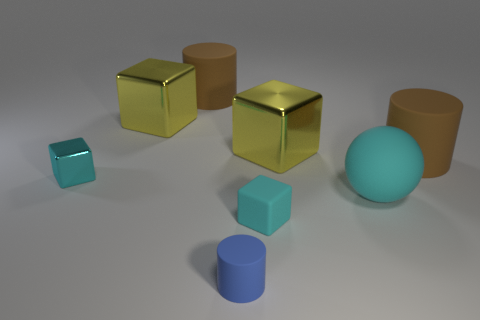What is the material of the ball that is the same color as the tiny shiny block?
Your answer should be compact. Rubber. How many cubes are behind the cyan metallic block and on the left side of the blue cylinder?
Offer a terse response. 1. Are there fewer small cyan rubber things behind the big cyan matte thing than metallic objects?
Your answer should be very brief. Yes. What shape is the matte object that is the same size as the cyan rubber cube?
Your answer should be compact. Cylinder. What number of other things are there of the same color as the tiny metal thing?
Provide a succinct answer. 2. Is the size of the cyan shiny block the same as the cyan matte cube?
Your answer should be very brief. Yes. How many objects are cyan rubber spheres or big metal objects behind the small blue cylinder?
Ensure brevity in your answer.  3. Are there fewer small blue rubber objects that are right of the blue cylinder than cubes that are right of the tiny cyan matte block?
Provide a succinct answer. Yes. What number of other objects are there of the same material as the large cyan object?
Your response must be concise. 4. Do the matte object on the left side of the blue matte object and the tiny rubber cube have the same color?
Provide a succinct answer. No. 